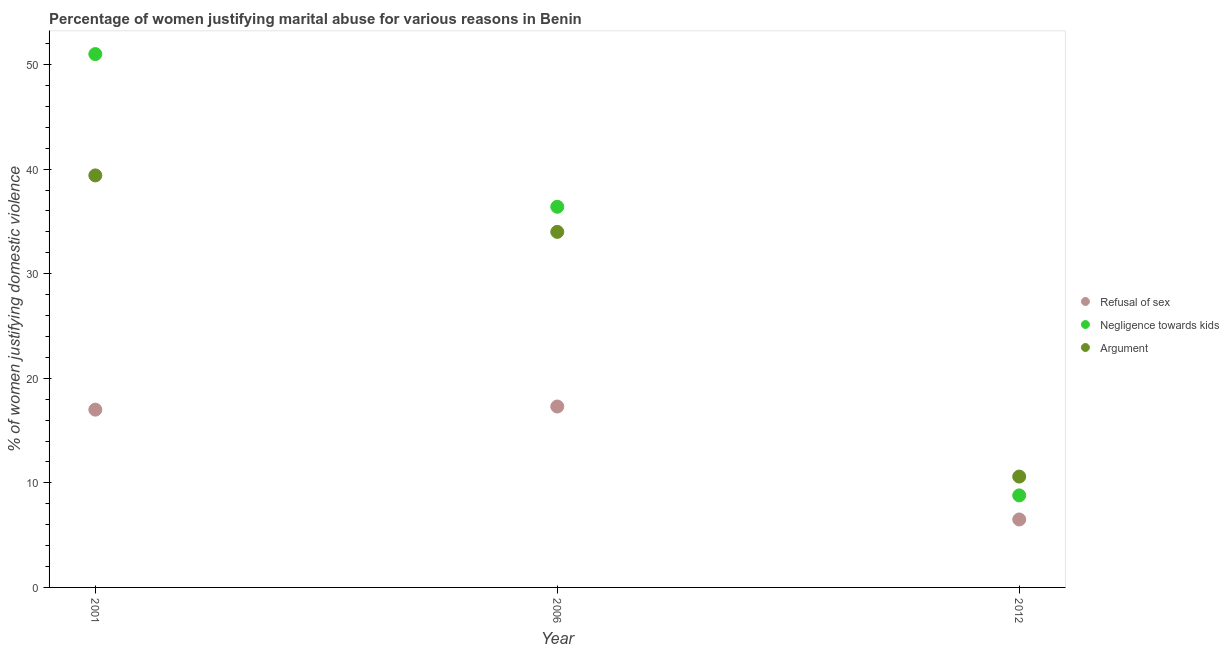How many different coloured dotlines are there?
Your response must be concise. 3. Across all years, what is the maximum percentage of women justifying domestic violence due to negligence towards kids?
Your response must be concise. 51. In which year was the percentage of women justifying domestic violence due to negligence towards kids minimum?
Your response must be concise. 2012. What is the total percentage of women justifying domestic violence due to refusal of sex in the graph?
Your answer should be compact. 40.8. What is the difference between the percentage of women justifying domestic violence due to negligence towards kids in 2006 and that in 2012?
Offer a very short reply. 27.6. What is the difference between the percentage of women justifying domestic violence due to negligence towards kids in 2006 and the percentage of women justifying domestic violence due to arguments in 2012?
Your answer should be very brief. 25.8. In the year 2006, what is the difference between the percentage of women justifying domestic violence due to negligence towards kids and percentage of women justifying domestic violence due to refusal of sex?
Provide a succinct answer. 19.1. What is the ratio of the percentage of women justifying domestic violence due to refusal of sex in 2001 to that in 2006?
Your response must be concise. 0.98. Is the difference between the percentage of women justifying domestic violence due to arguments in 2006 and 2012 greater than the difference between the percentage of women justifying domestic violence due to negligence towards kids in 2006 and 2012?
Offer a terse response. No. What is the difference between the highest and the second highest percentage of women justifying domestic violence due to arguments?
Your answer should be compact. 5.4. What is the difference between the highest and the lowest percentage of women justifying domestic violence due to refusal of sex?
Offer a very short reply. 10.8. Is the sum of the percentage of women justifying domestic violence due to negligence towards kids in 2001 and 2006 greater than the maximum percentage of women justifying domestic violence due to refusal of sex across all years?
Your answer should be compact. Yes. Is it the case that in every year, the sum of the percentage of women justifying domestic violence due to refusal of sex and percentage of women justifying domestic violence due to negligence towards kids is greater than the percentage of women justifying domestic violence due to arguments?
Your answer should be compact. Yes. Does the percentage of women justifying domestic violence due to refusal of sex monotonically increase over the years?
Your response must be concise. No. How many dotlines are there?
Provide a short and direct response. 3. How many years are there in the graph?
Make the answer very short. 3. Are the values on the major ticks of Y-axis written in scientific E-notation?
Offer a terse response. No. Does the graph contain any zero values?
Offer a terse response. No. Does the graph contain grids?
Provide a succinct answer. No. Where does the legend appear in the graph?
Your answer should be compact. Center right. How many legend labels are there?
Your response must be concise. 3. What is the title of the graph?
Keep it short and to the point. Percentage of women justifying marital abuse for various reasons in Benin. What is the label or title of the Y-axis?
Offer a very short reply. % of women justifying domestic violence. What is the % of women justifying domestic violence of Refusal of sex in 2001?
Ensure brevity in your answer.  17. What is the % of women justifying domestic violence in Negligence towards kids in 2001?
Your response must be concise. 51. What is the % of women justifying domestic violence of Argument in 2001?
Your response must be concise. 39.4. What is the % of women justifying domestic violence in Negligence towards kids in 2006?
Your answer should be compact. 36.4. What is the % of women justifying domestic violence of Refusal of sex in 2012?
Provide a succinct answer. 6.5. What is the % of women justifying domestic violence of Argument in 2012?
Your response must be concise. 10.6. Across all years, what is the maximum % of women justifying domestic violence of Refusal of sex?
Ensure brevity in your answer.  17.3. Across all years, what is the maximum % of women justifying domestic violence of Argument?
Provide a succinct answer. 39.4. Across all years, what is the minimum % of women justifying domestic violence of Refusal of sex?
Make the answer very short. 6.5. What is the total % of women justifying domestic violence of Refusal of sex in the graph?
Give a very brief answer. 40.8. What is the total % of women justifying domestic violence of Negligence towards kids in the graph?
Offer a very short reply. 96.2. What is the difference between the % of women justifying domestic violence of Negligence towards kids in 2001 and that in 2006?
Give a very brief answer. 14.6. What is the difference between the % of women justifying domestic violence in Refusal of sex in 2001 and that in 2012?
Keep it short and to the point. 10.5. What is the difference between the % of women justifying domestic violence of Negligence towards kids in 2001 and that in 2012?
Offer a very short reply. 42.2. What is the difference between the % of women justifying domestic violence of Argument in 2001 and that in 2012?
Provide a short and direct response. 28.8. What is the difference between the % of women justifying domestic violence in Refusal of sex in 2006 and that in 2012?
Provide a succinct answer. 10.8. What is the difference between the % of women justifying domestic violence in Negligence towards kids in 2006 and that in 2012?
Your response must be concise. 27.6. What is the difference between the % of women justifying domestic violence in Argument in 2006 and that in 2012?
Make the answer very short. 23.4. What is the difference between the % of women justifying domestic violence of Refusal of sex in 2001 and the % of women justifying domestic violence of Negligence towards kids in 2006?
Offer a terse response. -19.4. What is the difference between the % of women justifying domestic violence of Refusal of sex in 2001 and the % of women justifying domestic violence of Argument in 2006?
Your answer should be compact. -17. What is the difference between the % of women justifying domestic violence in Negligence towards kids in 2001 and the % of women justifying domestic violence in Argument in 2012?
Your response must be concise. 40.4. What is the difference between the % of women justifying domestic violence of Refusal of sex in 2006 and the % of women justifying domestic violence of Argument in 2012?
Offer a terse response. 6.7. What is the difference between the % of women justifying domestic violence of Negligence towards kids in 2006 and the % of women justifying domestic violence of Argument in 2012?
Your answer should be very brief. 25.8. What is the average % of women justifying domestic violence of Refusal of sex per year?
Keep it short and to the point. 13.6. What is the average % of women justifying domestic violence of Negligence towards kids per year?
Provide a short and direct response. 32.07. In the year 2001, what is the difference between the % of women justifying domestic violence in Refusal of sex and % of women justifying domestic violence in Negligence towards kids?
Your answer should be very brief. -34. In the year 2001, what is the difference between the % of women justifying domestic violence in Refusal of sex and % of women justifying domestic violence in Argument?
Provide a short and direct response. -22.4. In the year 2001, what is the difference between the % of women justifying domestic violence of Negligence towards kids and % of women justifying domestic violence of Argument?
Provide a succinct answer. 11.6. In the year 2006, what is the difference between the % of women justifying domestic violence of Refusal of sex and % of women justifying domestic violence of Negligence towards kids?
Offer a terse response. -19.1. In the year 2006, what is the difference between the % of women justifying domestic violence in Refusal of sex and % of women justifying domestic violence in Argument?
Give a very brief answer. -16.7. In the year 2006, what is the difference between the % of women justifying domestic violence in Negligence towards kids and % of women justifying domestic violence in Argument?
Provide a succinct answer. 2.4. In the year 2012, what is the difference between the % of women justifying domestic violence in Refusal of sex and % of women justifying domestic violence in Negligence towards kids?
Ensure brevity in your answer.  -2.3. What is the ratio of the % of women justifying domestic violence in Refusal of sex in 2001 to that in 2006?
Make the answer very short. 0.98. What is the ratio of the % of women justifying domestic violence of Negligence towards kids in 2001 to that in 2006?
Offer a very short reply. 1.4. What is the ratio of the % of women justifying domestic violence in Argument in 2001 to that in 2006?
Your answer should be very brief. 1.16. What is the ratio of the % of women justifying domestic violence of Refusal of sex in 2001 to that in 2012?
Your answer should be very brief. 2.62. What is the ratio of the % of women justifying domestic violence of Negligence towards kids in 2001 to that in 2012?
Make the answer very short. 5.8. What is the ratio of the % of women justifying domestic violence in Argument in 2001 to that in 2012?
Offer a terse response. 3.72. What is the ratio of the % of women justifying domestic violence in Refusal of sex in 2006 to that in 2012?
Keep it short and to the point. 2.66. What is the ratio of the % of women justifying domestic violence of Negligence towards kids in 2006 to that in 2012?
Your answer should be compact. 4.14. What is the ratio of the % of women justifying domestic violence of Argument in 2006 to that in 2012?
Make the answer very short. 3.21. What is the difference between the highest and the second highest % of women justifying domestic violence in Refusal of sex?
Keep it short and to the point. 0.3. What is the difference between the highest and the lowest % of women justifying domestic violence in Negligence towards kids?
Keep it short and to the point. 42.2. What is the difference between the highest and the lowest % of women justifying domestic violence of Argument?
Your answer should be compact. 28.8. 